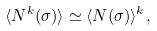<formula> <loc_0><loc_0><loc_500><loc_500>\langle N ^ { k } ( \sigma ) \rangle \simeq \langle N ( \sigma ) \rangle ^ { k } ,</formula> 